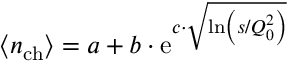Convert formula to latex. <formula><loc_0><loc_0><loc_500><loc_500>\left < n _ { c h } \right > = a + b \cdot e ^ { c \cdot \sqrt { \ln \left ( s / Q _ { 0 } ^ { 2 } \right ) } }</formula> 